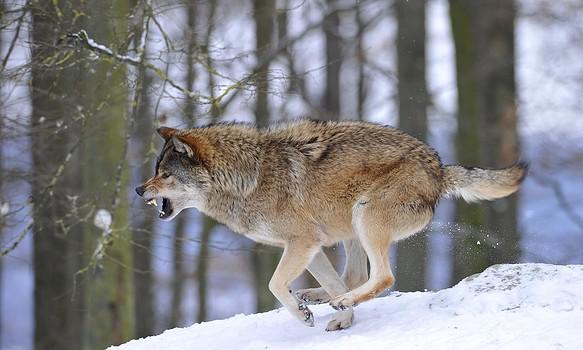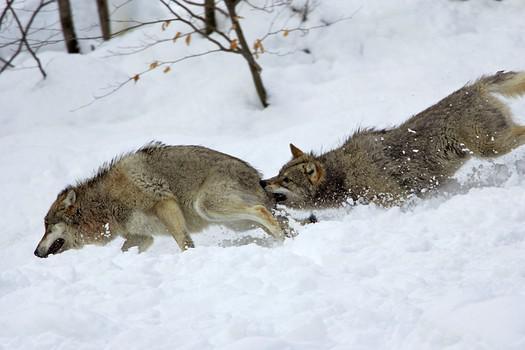The first image is the image on the left, the second image is the image on the right. For the images displayed, is the sentence "The right image contains exactly two wolves." factually correct? Answer yes or no. Yes. The first image is the image on the left, the second image is the image on the right. Given the left and right images, does the statement "One image shows a single wolf in confrontation with a group of wolves that outnumber it about 5-to1." hold true? Answer yes or no. No. 